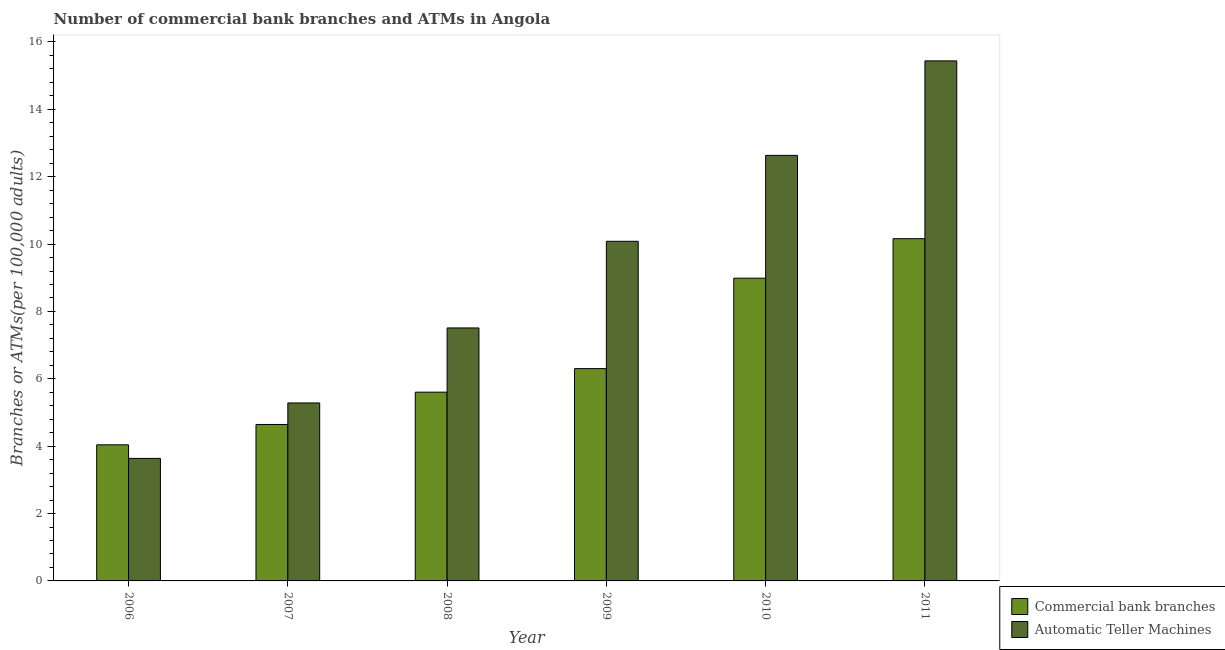Are the number of bars per tick equal to the number of legend labels?
Provide a succinct answer. Yes. How many bars are there on the 3rd tick from the left?
Your answer should be very brief. 2. What is the label of the 1st group of bars from the left?
Offer a terse response. 2006. In how many cases, is the number of bars for a given year not equal to the number of legend labels?
Your response must be concise. 0. What is the number of commercal bank branches in 2010?
Your response must be concise. 8.99. Across all years, what is the maximum number of commercal bank branches?
Provide a succinct answer. 10.16. Across all years, what is the minimum number of atms?
Offer a very short reply. 3.64. What is the total number of commercal bank branches in the graph?
Keep it short and to the point. 39.74. What is the difference between the number of atms in 2006 and that in 2008?
Your answer should be very brief. -3.87. What is the difference between the number of commercal bank branches in 2011 and the number of atms in 2008?
Provide a short and direct response. 4.56. What is the average number of commercal bank branches per year?
Give a very brief answer. 6.62. In the year 2009, what is the difference between the number of commercal bank branches and number of atms?
Keep it short and to the point. 0. In how many years, is the number of commercal bank branches greater than 4.4?
Give a very brief answer. 5. What is the ratio of the number of commercal bank branches in 2006 to that in 2009?
Provide a succinct answer. 0.64. Is the number of atms in 2007 less than that in 2008?
Your response must be concise. Yes. Is the difference between the number of commercal bank branches in 2006 and 2009 greater than the difference between the number of atms in 2006 and 2009?
Offer a very short reply. No. What is the difference between the highest and the second highest number of atms?
Keep it short and to the point. 2.81. What is the difference between the highest and the lowest number of commercal bank branches?
Your response must be concise. 6.12. In how many years, is the number of commercal bank branches greater than the average number of commercal bank branches taken over all years?
Your answer should be very brief. 2. Is the sum of the number of atms in 2008 and 2010 greater than the maximum number of commercal bank branches across all years?
Your response must be concise. Yes. What does the 2nd bar from the left in 2010 represents?
Make the answer very short. Automatic Teller Machines. What does the 1st bar from the right in 2009 represents?
Provide a succinct answer. Automatic Teller Machines. How many bars are there?
Give a very brief answer. 12. How many years are there in the graph?
Give a very brief answer. 6. What is the difference between two consecutive major ticks on the Y-axis?
Your answer should be compact. 2. Are the values on the major ticks of Y-axis written in scientific E-notation?
Your response must be concise. No. Does the graph contain any zero values?
Provide a short and direct response. No. Does the graph contain grids?
Keep it short and to the point. No. Where does the legend appear in the graph?
Your response must be concise. Bottom right. How many legend labels are there?
Provide a short and direct response. 2. What is the title of the graph?
Keep it short and to the point. Number of commercial bank branches and ATMs in Angola. What is the label or title of the X-axis?
Make the answer very short. Year. What is the label or title of the Y-axis?
Your answer should be compact. Branches or ATMs(per 100,0 adults). What is the Branches or ATMs(per 100,000 adults) of Commercial bank branches in 2006?
Offer a terse response. 4.04. What is the Branches or ATMs(per 100,000 adults) in Automatic Teller Machines in 2006?
Your response must be concise. 3.64. What is the Branches or ATMs(per 100,000 adults) in Commercial bank branches in 2007?
Give a very brief answer. 4.64. What is the Branches or ATMs(per 100,000 adults) in Automatic Teller Machines in 2007?
Your answer should be compact. 5.28. What is the Branches or ATMs(per 100,000 adults) in Commercial bank branches in 2008?
Provide a succinct answer. 5.6. What is the Branches or ATMs(per 100,000 adults) in Automatic Teller Machines in 2008?
Your response must be concise. 7.51. What is the Branches or ATMs(per 100,000 adults) of Commercial bank branches in 2009?
Give a very brief answer. 6.3. What is the Branches or ATMs(per 100,000 adults) of Automatic Teller Machines in 2009?
Your answer should be compact. 10.08. What is the Branches or ATMs(per 100,000 adults) of Commercial bank branches in 2010?
Your response must be concise. 8.99. What is the Branches or ATMs(per 100,000 adults) of Automatic Teller Machines in 2010?
Provide a short and direct response. 12.63. What is the Branches or ATMs(per 100,000 adults) in Commercial bank branches in 2011?
Offer a very short reply. 10.16. What is the Branches or ATMs(per 100,000 adults) in Automatic Teller Machines in 2011?
Make the answer very short. 15.44. Across all years, what is the maximum Branches or ATMs(per 100,000 adults) in Commercial bank branches?
Ensure brevity in your answer.  10.16. Across all years, what is the maximum Branches or ATMs(per 100,000 adults) in Automatic Teller Machines?
Keep it short and to the point. 15.44. Across all years, what is the minimum Branches or ATMs(per 100,000 adults) of Commercial bank branches?
Your response must be concise. 4.04. Across all years, what is the minimum Branches or ATMs(per 100,000 adults) of Automatic Teller Machines?
Your answer should be compact. 3.64. What is the total Branches or ATMs(per 100,000 adults) in Commercial bank branches in the graph?
Keep it short and to the point. 39.74. What is the total Branches or ATMs(per 100,000 adults) in Automatic Teller Machines in the graph?
Provide a short and direct response. 54.58. What is the difference between the Branches or ATMs(per 100,000 adults) in Commercial bank branches in 2006 and that in 2007?
Your answer should be very brief. -0.6. What is the difference between the Branches or ATMs(per 100,000 adults) in Automatic Teller Machines in 2006 and that in 2007?
Make the answer very short. -1.65. What is the difference between the Branches or ATMs(per 100,000 adults) of Commercial bank branches in 2006 and that in 2008?
Your response must be concise. -1.56. What is the difference between the Branches or ATMs(per 100,000 adults) in Automatic Teller Machines in 2006 and that in 2008?
Your answer should be compact. -3.87. What is the difference between the Branches or ATMs(per 100,000 adults) in Commercial bank branches in 2006 and that in 2009?
Make the answer very short. -2.26. What is the difference between the Branches or ATMs(per 100,000 adults) in Automatic Teller Machines in 2006 and that in 2009?
Offer a very short reply. -6.45. What is the difference between the Branches or ATMs(per 100,000 adults) in Commercial bank branches in 2006 and that in 2010?
Your answer should be very brief. -4.95. What is the difference between the Branches or ATMs(per 100,000 adults) of Automatic Teller Machines in 2006 and that in 2010?
Your answer should be compact. -9. What is the difference between the Branches or ATMs(per 100,000 adults) of Commercial bank branches in 2006 and that in 2011?
Offer a terse response. -6.12. What is the difference between the Branches or ATMs(per 100,000 adults) of Automatic Teller Machines in 2006 and that in 2011?
Your response must be concise. -11.8. What is the difference between the Branches or ATMs(per 100,000 adults) in Commercial bank branches in 2007 and that in 2008?
Give a very brief answer. -0.96. What is the difference between the Branches or ATMs(per 100,000 adults) in Automatic Teller Machines in 2007 and that in 2008?
Your answer should be very brief. -2.23. What is the difference between the Branches or ATMs(per 100,000 adults) in Commercial bank branches in 2007 and that in 2009?
Provide a short and direct response. -1.66. What is the difference between the Branches or ATMs(per 100,000 adults) of Automatic Teller Machines in 2007 and that in 2009?
Give a very brief answer. -4.8. What is the difference between the Branches or ATMs(per 100,000 adults) of Commercial bank branches in 2007 and that in 2010?
Offer a very short reply. -4.34. What is the difference between the Branches or ATMs(per 100,000 adults) of Automatic Teller Machines in 2007 and that in 2010?
Ensure brevity in your answer.  -7.35. What is the difference between the Branches or ATMs(per 100,000 adults) of Commercial bank branches in 2007 and that in 2011?
Keep it short and to the point. -5.52. What is the difference between the Branches or ATMs(per 100,000 adults) in Automatic Teller Machines in 2007 and that in 2011?
Ensure brevity in your answer.  -10.16. What is the difference between the Branches or ATMs(per 100,000 adults) in Commercial bank branches in 2008 and that in 2009?
Keep it short and to the point. -0.7. What is the difference between the Branches or ATMs(per 100,000 adults) in Automatic Teller Machines in 2008 and that in 2009?
Ensure brevity in your answer.  -2.57. What is the difference between the Branches or ATMs(per 100,000 adults) of Commercial bank branches in 2008 and that in 2010?
Keep it short and to the point. -3.38. What is the difference between the Branches or ATMs(per 100,000 adults) in Automatic Teller Machines in 2008 and that in 2010?
Provide a succinct answer. -5.12. What is the difference between the Branches or ATMs(per 100,000 adults) in Commercial bank branches in 2008 and that in 2011?
Give a very brief answer. -4.56. What is the difference between the Branches or ATMs(per 100,000 adults) in Automatic Teller Machines in 2008 and that in 2011?
Offer a terse response. -7.93. What is the difference between the Branches or ATMs(per 100,000 adults) of Commercial bank branches in 2009 and that in 2010?
Offer a very short reply. -2.68. What is the difference between the Branches or ATMs(per 100,000 adults) in Automatic Teller Machines in 2009 and that in 2010?
Offer a very short reply. -2.55. What is the difference between the Branches or ATMs(per 100,000 adults) in Commercial bank branches in 2009 and that in 2011?
Your answer should be compact. -3.86. What is the difference between the Branches or ATMs(per 100,000 adults) in Automatic Teller Machines in 2009 and that in 2011?
Your response must be concise. -5.36. What is the difference between the Branches or ATMs(per 100,000 adults) of Commercial bank branches in 2010 and that in 2011?
Your answer should be compact. -1.17. What is the difference between the Branches or ATMs(per 100,000 adults) in Automatic Teller Machines in 2010 and that in 2011?
Offer a very short reply. -2.81. What is the difference between the Branches or ATMs(per 100,000 adults) in Commercial bank branches in 2006 and the Branches or ATMs(per 100,000 adults) in Automatic Teller Machines in 2007?
Give a very brief answer. -1.24. What is the difference between the Branches or ATMs(per 100,000 adults) in Commercial bank branches in 2006 and the Branches or ATMs(per 100,000 adults) in Automatic Teller Machines in 2008?
Give a very brief answer. -3.47. What is the difference between the Branches or ATMs(per 100,000 adults) of Commercial bank branches in 2006 and the Branches or ATMs(per 100,000 adults) of Automatic Teller Machines in 2009?
Give a very brief answer. -6.04. What is the difference between the Branches or ATMs(per 100,000 adults) of Commercial bank branches in 2006 and the Branches or ATMs(per 100,000 adults) of Automatic Teller Machines in 2010?
Your response must be concise. -8.59. What is the difference between the Branches or ATMs(per 100,000 adults) of Commercial bank branches in 2006 and the Branches or ATMs(per 100,000 adults) of Automatic Teller Machines in 2011?
Keep it short and to the point. -11.4. What is the difference between the Branches or ATMs(per 100,000 adults) of Commercial bank branches in 2007 and the Branches or ATMs(per 100,000 adults) of Automatic Teller Machines in 2008?
Provide a succinct answer. -2.87. What is the difference between the Branches or ATMs(per 100,000 adults) of Commercial bank branches in 2007 and the Branches or ATMs(per 100,000 adults) of Automatic Teller Machines in 2009?
Offer a very short reply. -5.44. What is the difference between the Branches or ATMs(per 100,000 adults) of Commercial bank branches in 2007 and the Branches or ATMs(per 100,000 adults) of Automatic Teller Machines in 2010?
Your response must be concise. -7.99. What is the difference between the Branches or ATMs(per 100,000 adults) of Commercial bank branches in 2007 and the Branches or ATMs(per 100,000 adults) of Automatic Teller Machines in 2011?
Ensure brevity in your answer.  -10.79. What is the difference between the Branches or ATMs(per 100,000 adults) of Commercial bank branches in 2008 and the Branches or ATMs(per 100,000 adults) of Automatic Teller Machines in 2009?
Your response must be concise. -4.48. What is the difference between the Branches or ATMs(per 100,000 adults) of Commercial bank branches in 2008 and the Branches or ATMs(per 100,000 adults) of Automatic Teller Machines in 2010?
Ensure brevity in your answer.  -7.03. What is the difference between the Branches or ATMs(per 100,000 adults) of Commercial bank branches in 2008 and the Branches or ATMs(per 100,000 adults) of Automatic Teller Machines in 2011?
Ensure brevity in your answer.  -9.83. What is the difference between the Branches or ATMs(per 100,000 adults) in Commercial bank branches in 2009 and the Branches or ATMs(per 100,000 adults) in Automatic Teller Machines in 2010?
Ensure brevity in your answer.  -6.33. What is the difference between the Branches or ATMs(per 100,000 adults) in Commercial bank branches in 2009 and the Branches or ATMs(per 100,000 adults) in Automatic Teller Machines in 2011?
Your answer should be very brief. -9.14. What is the difference between the Branches or ATMs(per 100,000 adults) in Commercial bank branches in 2010 and the Branches or ATMs(per 100,000 adults) in Automatic Teller Machines in 2011?
Your answer should be very brief. -6.45. What is the average Branches or ATMs(per 100,000 adults) in Commercial bank branches per year?
Provide a short and direct response. 6.62. What is the average Branches or ATMs(per 100,000 adults) in Automatic Teller Machines per year?
Your answer should be very brief. 9.1. In the year 2006, what is the difference between the Branches or ATMs(per 100,000 adults) of Commercial bank branches and Branches or ATMs(per 100,000 adults) of Automatic Teller Machines?
Provide a succinct answer. 0.4. In the year 2007, what is the difference between the Branches or ATMs(per 100,000 adults) of Commercial bank branches and Branches or ATMs(per 100,000 adults) of Automatic Teller Machines?
Offer a very short reply. -0.64. In the year 2008, what is the difference between the Branches or ATMs(per 100,000 adults) of Commercial bank branches and Branches or ATMs(per 100,000 adults) of Automatic Teller Machines?
Your answer should be compact. -1.91. In the year 2009, what is the difference between the Branches or ATMs(per 100,000 adults) in Commercial bank branches and Branches or ATMs(per 100,000 adults) in Automatic Teller Machines?
Keep it short and to the point. -3.78. In the year 2010, what is the difference between the Branches or ATMs(per 100,000 adults) in Commercial bank branches and Branches or ATMs(per 100,000 adults) in Automatic Teller Machines?
Offer a very short reply. -3.65. In the year 2011, what is the difference between the Branches or ATMs(per 100,000 adults) of Commercial bank branches and Branches or ATMs(per 100,000 adults) of Automatic Teller Machines?
Give a very brief answer. -5.28. What is the ratio of the Branches or ATMs(per 100,000 adults) of Commercial bank branches in 2006 to that in 2007?
Your answer should be very brief. 0.87. What is the ratio of the Branches or ATMs(per 100,000 adults) of Automatic Teller Machines in 2006 to that in 2007?
Offer a terse response. 0.69. What is the ratio of the Branches or ATMs(per 100,000 adults) in Commercial bank branches in 2006 to that in 2008?
Offer a terse response. 0.72. What is the ratio of the Branches or ATMs(per 100,000 adults) in Automatic Teller Machines in 2006 to that in 2008?
Your response must be concise. 0.48. What is the ratio of the Branches or ATMs(per 100,000 adults) of Commercial bank branches in 2006 to that in 2009?
Give a very brief answer. 0.64. What is the ratio of the Branches or ATMs(per 100,000 adults) in Automatic Teller Machines in 2006 to that in 2009?
Provide a succinct answer. 0.36. What is the ratio of the Branches or ATMs(per 100,000 adults) in Commercial bank branches in 2006 to that in 2010?
Your response must be concise. 0.45. What is the ratio of the Branches or ATMs(per 100,000 adults) in Automatic Teller Machines in 2006 to that in 2010?
Your answer should be compact. 0.29. What is the ratio of the Branches or ATMs(per 100,000 adults) of Commercial bank branches in 2006 to that in 2011?
Ensure brevity in your answer.  0.4. What is the ratio of the Branches or ATMs(per 100,000 adults) in Automatic Teller Machines in 2006 to that in 2011?
Your answer should be very brief. 0.24. What is the ratio of the Branches or ATMs(per 100,000 adults) in Commercial bank branches in 2007 to that in 2008?
Offer a terse response. 0.83. What is the ratio of the Branches or ATMs(per 100,000 adults) in Automatic Teller Machines in 2007 to that in 2008?
Give a very brief answer. 0.7. What is the ratio of the Branches or ATMs(per 100,000 adults) in Commercial bank branches in 2007 to that in 2009?
Your response must be concise. 0.74. What is the ratio of the Branches or ATMs(per 100,000 adults) of Automatic Teller Machines in 2007 to that in 2009?
Your answer should be compact. 0.52. What is the ratio of the Branches or ATMs(per 100,000 adults) in Commercial bank branches in 2007 to that in 2010?
Keep it short and to the point. 0.52. What is the ratio of the Branches or ATMs(per 100,000 adults) of Automatic Teller Machines in 2007 to that in 2010?
Make the answer very short. 0.42. What is the ratio of the Branches or ATMs(per 100,000 adults) of Commercial bank branches in 2007 to that in 2011?
Your response must be concise. 0.46. What is the ratio of the Branches or ATMs(per 100,000 adults) in Automatic Teller Machines in 2007 to that in 2011?
Offer a very short reply. 0.34. What is the ratio of the Branches or ATMs(per 100,000 adults) in Commercial bank branches in 2008 to that in 2009?
Keep it short and to the point. 0.89. What is the ratio of the Branches or ATMs(per 100,000 adults) of Automatic Teller Machines in 2008 to that in 2009?
Provide a short and direct response. 0.74. What is the ratio of the Branches or ATMs(per 100,000 adults) in Commercial bank branches in 2008 to that in 2010?
Offer a terse response. 0.62. What is the ratio of the Branches or ATMs(per 100,000 adults) in Automatic Teller Machines in 2008 to that in 2010?
Provide a succinct answer. 0.59. What is the ratio of the Branches or ATMs(per 100,000 adults) in Commercial bank branches in 2008 to that in 2011?
Your answer should be compact. 0.55. What is the ratio of the Branches or ATMs(per 100,000 adults) in Automatic Teller Machines in 2008 to that in 2011?
Make the answer very short. 0.49. What is the ratio of the Branches or ATMs(per 100,000 adults) in Commercial bank branches in 2009 to that in 2010?
Your response must be concise. 0.7. What is the ratio of the Branches or ATMs(per 100,000 adults) of Automatic Teller Machines in 2009 to that in 2010?
Your answer should be compact. 0.8. What is the ratio of the Branches or ATMs(per 100,000 adults) in Commercial bank branches in 2009 to that in 2011?
Offer a terse response. 0.62. What is the ratio of the Branches or ATMs(per 100,000 adults) in Automatic Teller Machines in 2009 to that in 2011?
Your answer should be very brief. 0.65. What is the ratio of the Branches or ATMs(per 100,000 adults) in Commercial bank branches in 2010 to that in 2011?
Make the answer very short. 0.88. What is the ratio of the Branches or ATMs(per 100,000 adults) of Automatic Teller Machines in 2010 to that in 2011?
Your answer should be compact. 0.82. What is the difference between the highest and the second highest Branches or ATMs(per 100,000 adults) in Commercial bank branches?
Ensure brevity in your answer.  1.17. What is the difference between the highest and the second highest Branches or ATMs(per 100,000 adults) of Automatic Teller Machines?
Offer a terse response. 2.81. What is the difference between the highest and the lowest Branches or ATMs(per 100,000 adults) of Commercial bank branches?
Provide a succinct answer. 6.12. What is the difference between the highest and the lowest Branches or ATMs(per 100,000 adults) of Automatic Teller Machines?
Give a very brief answer. 11.8. 